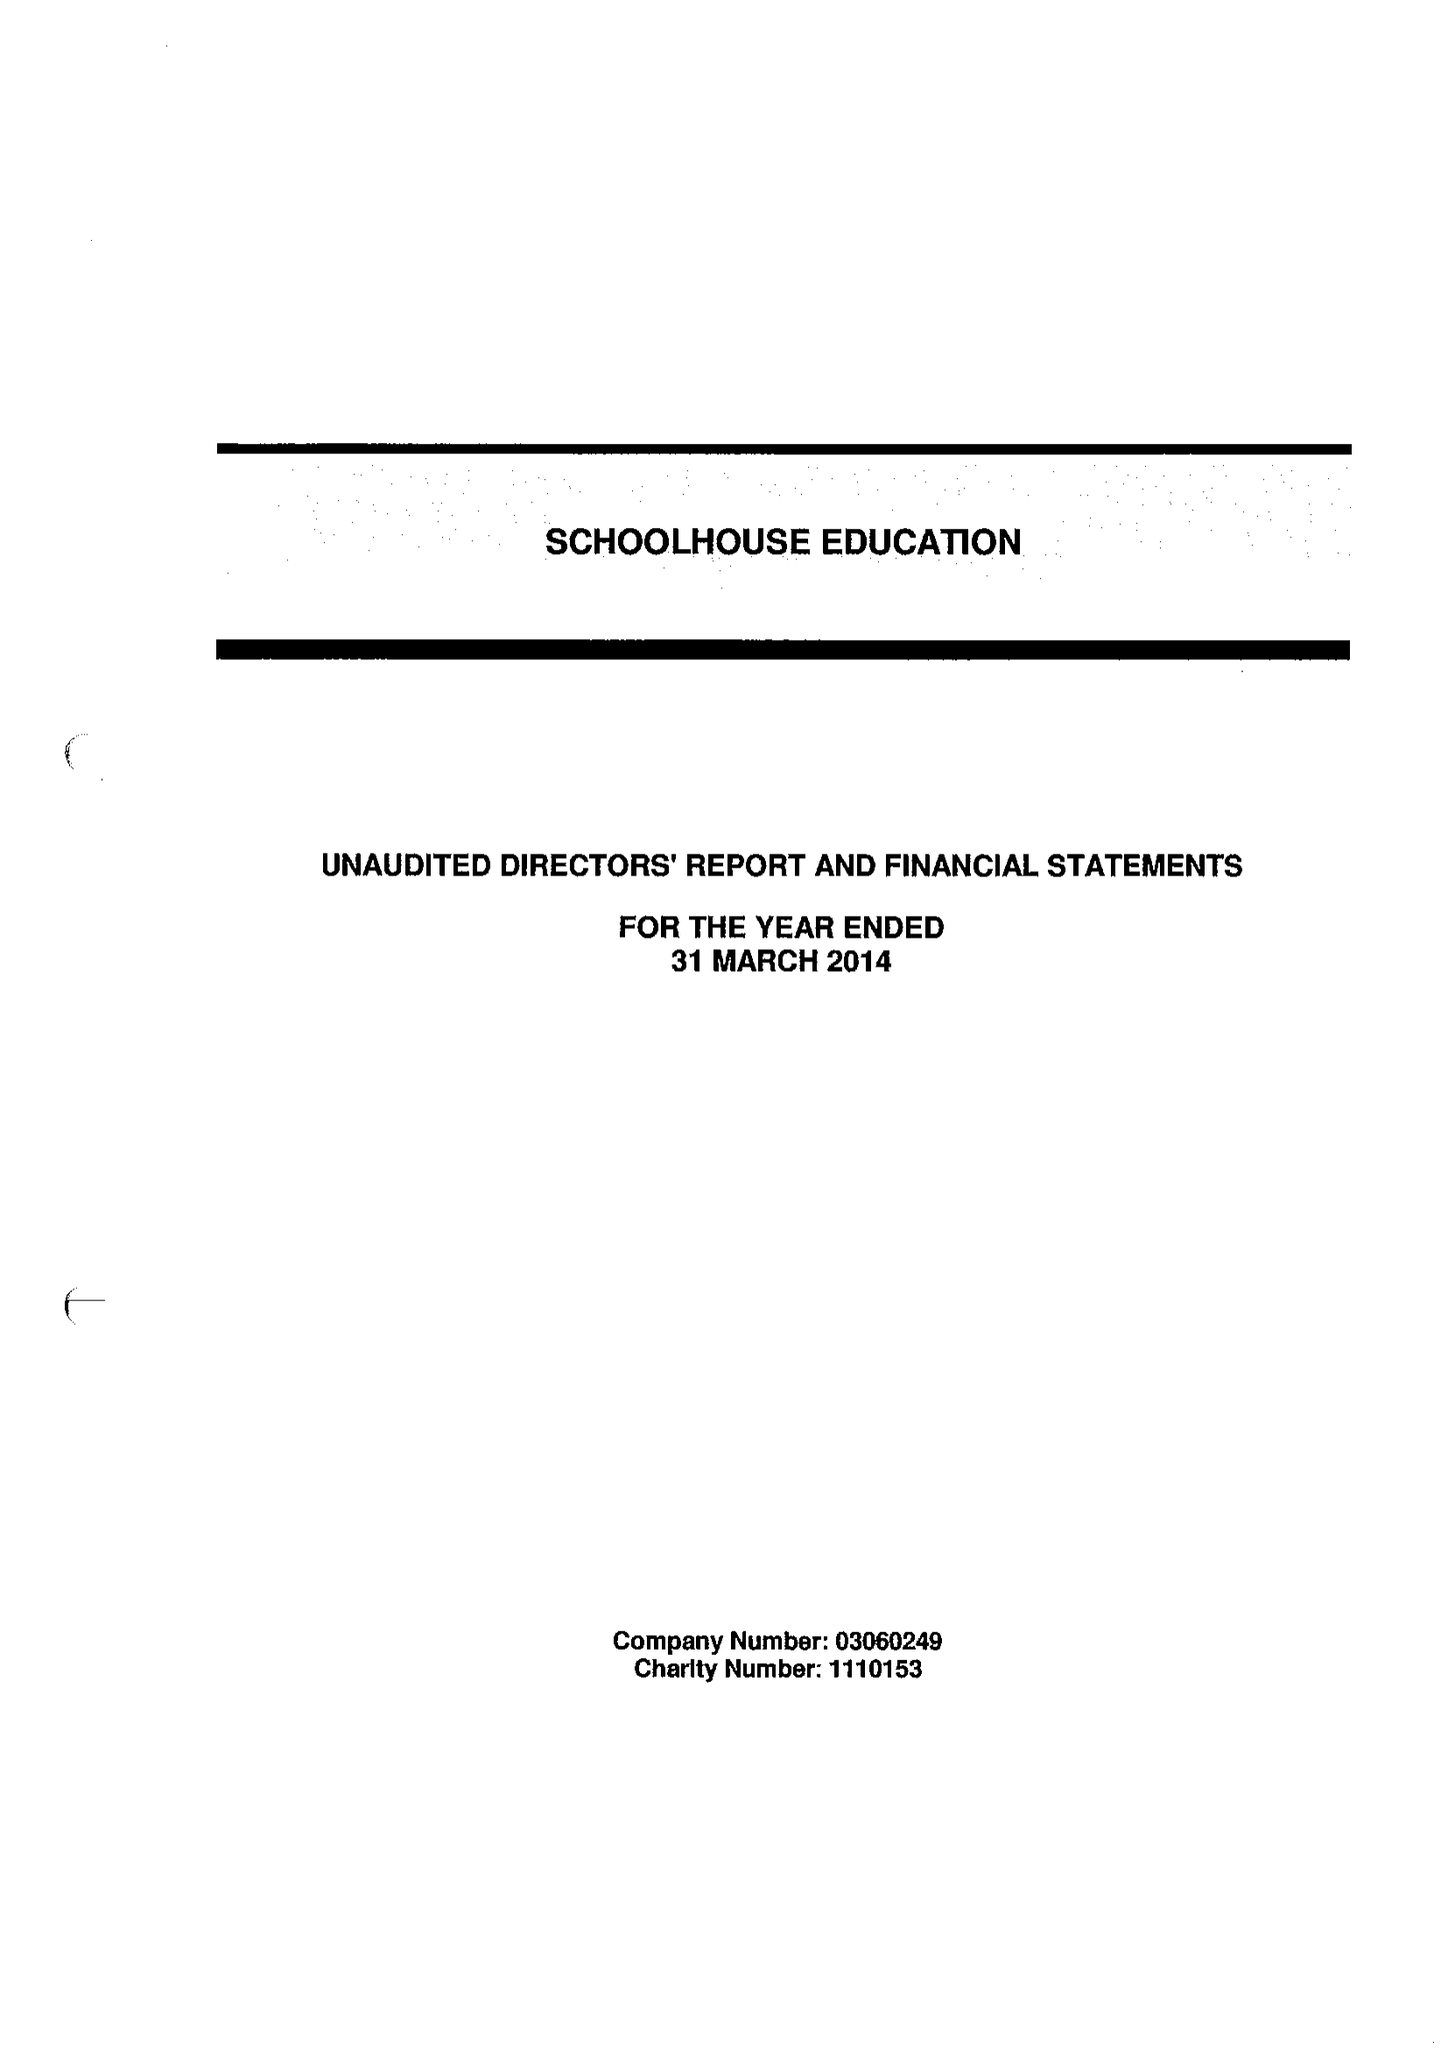What is the value for the income_annually_in_british_pounds?
Answer the question using a single word or phrase. 321740.00 